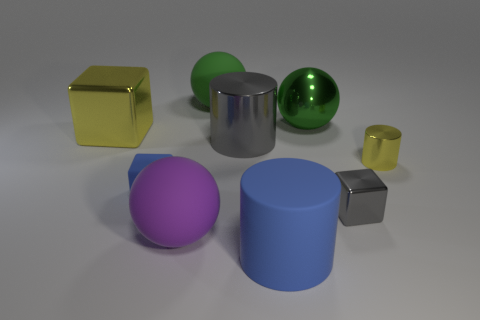What shape is the small matte object that is the same color as the rubber cylinder?
Ensure brevity in your answer.  Cube. Are there fewer red rubber cubes than large yellow shiny cubes?
Provide a succinct answer. Yes. Are there any things of the same size as the yellow metal cylinder?
Offer a terse response. Yes. Is the shape of the small blue matte object the same as the metal object to the left of the big purple matte sphere?
Your answer should be compact. Yes. How many cylinders are shiny things or tiny blue things?
Your response must be concise. 2. The big shiny sphere has what color?
Your response must be concise. Green. Are there more big spheres than purple things?
Your answer should be very brief. Yes. How many things are gray objects to the left of the yellow shiny cylinder or large cylinders?
Provide a short and direct response. 3. Does the small gray object have the same material as the small blue object?
Offer a terse response. No. What is the size of the other shiny object that is the same shape as the large gray object?
Provide a succinct answer. Small. 